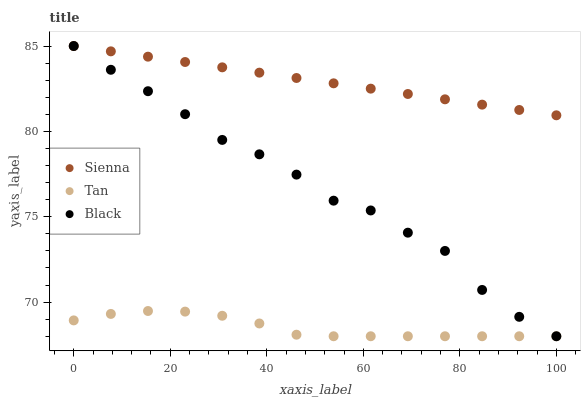Does Tan have the minimum area under the curve?
Answer yes or no. Yes. Does Sienna have the maximum area under the curve?
Answer yes or no. Yes. Does Black have the minimum area under the curve?
Answer yes or no. No. Does Black have the maximum area under the curve?
Answer yes or no. No. Is Sienna the smoothest?
Answer yes or no. Yes. Is Black the roughest?
Answer yes or no. Yes. Is Tan the smoothest?
Answer yes or no. No. Is Tan the roughest?
Answer yes or no. No. Does Tan have the lowest value?
Answer yes or no. Yes. Does Black have the highest value?
Answer yes or no. Yes. Does Tan have the highest value?
Answer yes or no. No. Is Tan less than Sienna?
Answer yes or no. Yes. Is Sienna greater than Tan?
Answer yes or no. Yes. Does Sienna intersect Black?
Answer yes or no. Yes. Is Sienna less than Black?
Answer yes or no. No. Is Sienna greater than Black?
Answer yes or no. No. Does Tan intersect Sienna?
Answer yes or no. No. 